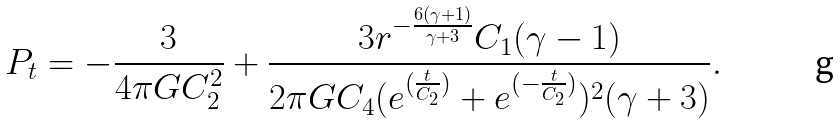Convert formula to latex. <formula><loc_0><loc_0><loc_500><loc_500>P _ { t } = - \frac { 3 } { 4 \pi G C _ { 2 } ^ { 2 } } + \frac { 3 r ^ { - \frac { 6 ( \gamma + 1 ) } { \gamma + 3 } } C _ { 1 } ( \gamma - 1 ) } { 2 \pi G C _ { 4 } ( e ^ { ( \frac { t } { C _ { 2 } } ) } + e ^ { ( - \frac { t } { C _ { 2 } } ) } ) ^ { 2 } ( \gamma + 3 ) } .</formula> 